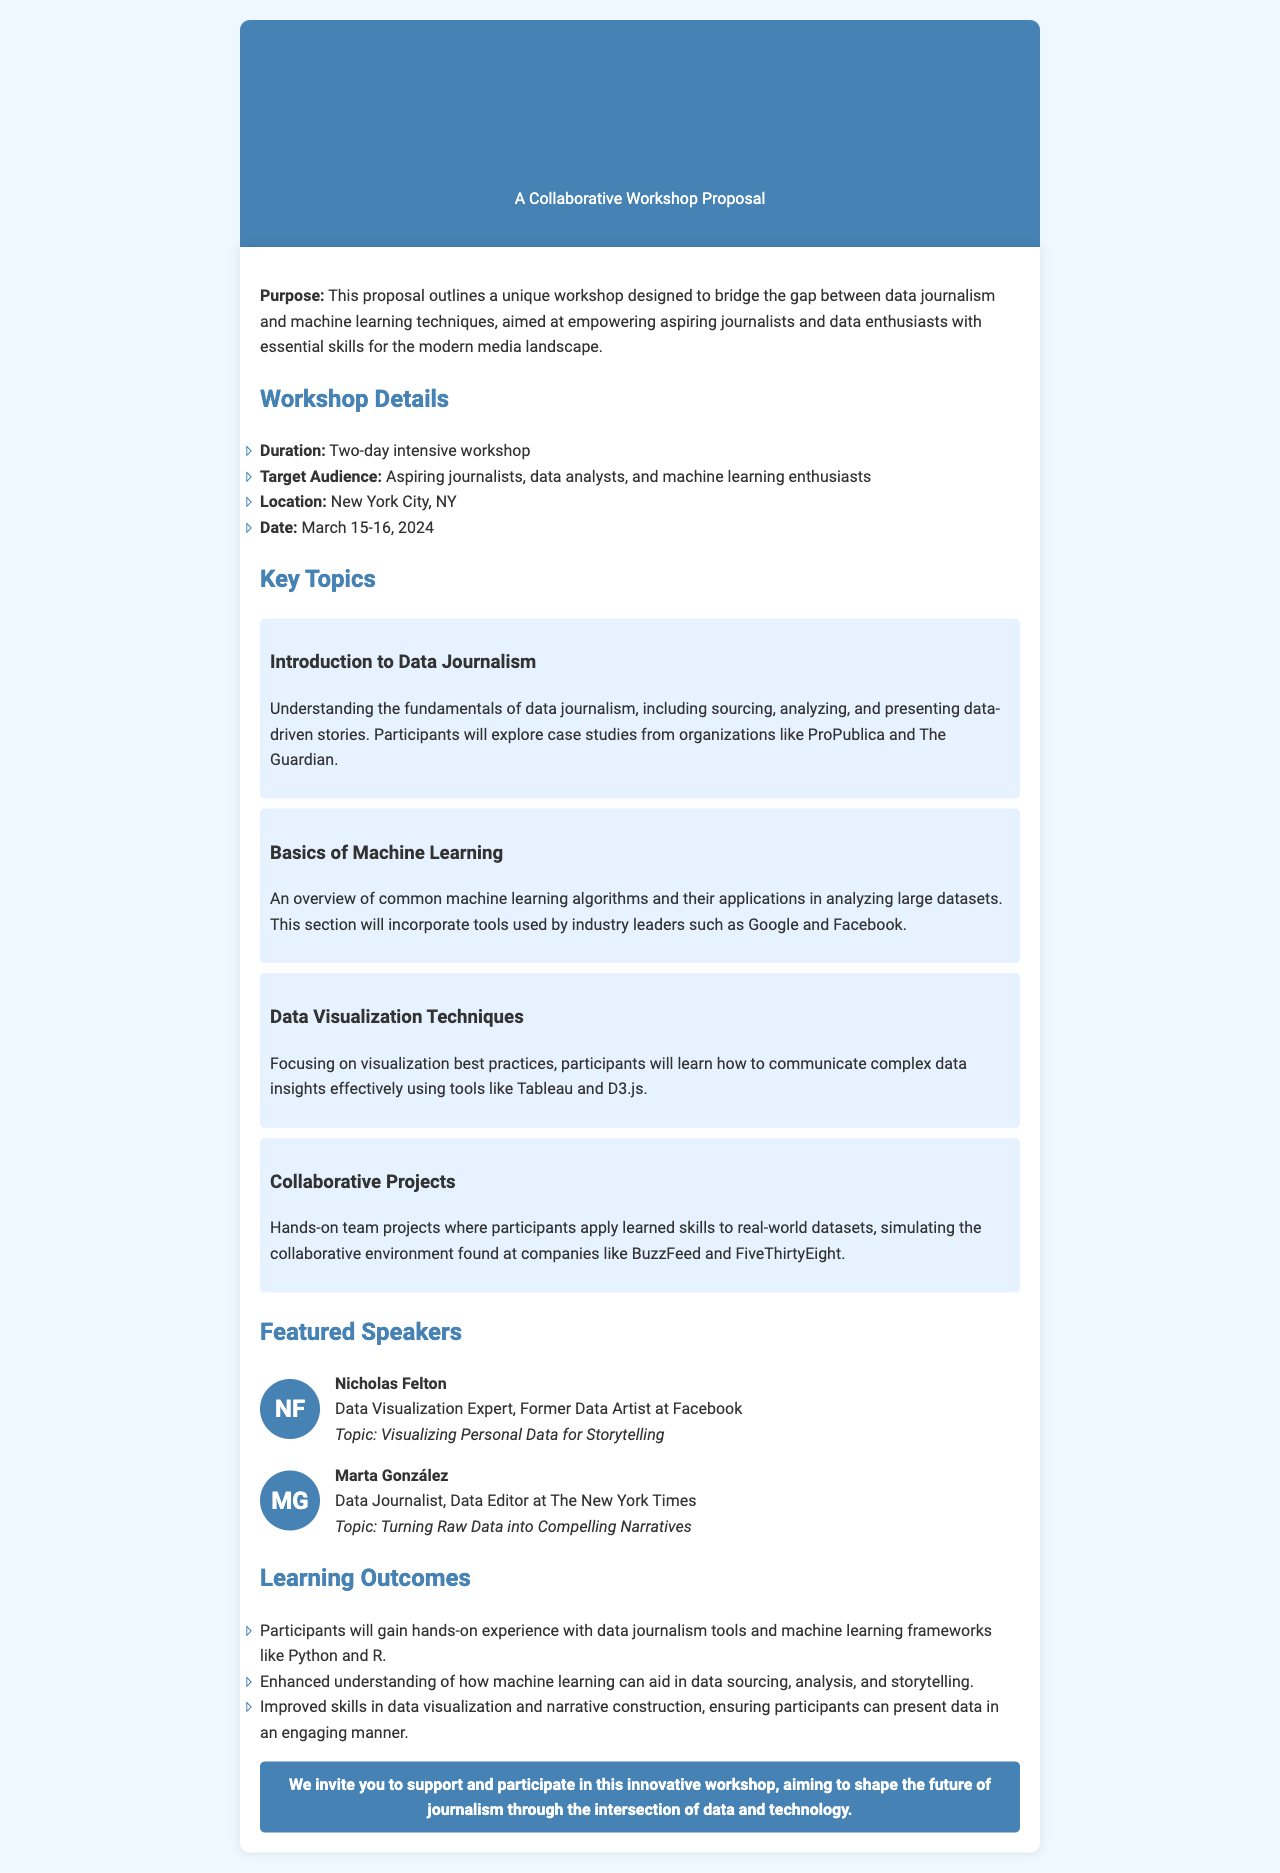What is the title of the workshop proposal? The title of the workshop proposal is stated at the top of the document, emphasizing the collaborative aspect of data journalism and machine learning.
Answer: Data-Driven Storytelling: Leveraging Machine Learning in Journalism What are the workshop dates? The specific dates for the workshop are mentioned under the workshop details section of the document.
Answer: March 15-16, 2024 Who is the data visualization expert speaker? The document lists specific speakers along with their roles and topics, identifying Nicholas Felton as the expert in data visualization.
Answer: Nicholas Felton What is one of the key topics covered in the workshop? The document highlights several key topics; one example is given which explains the content of the workshop.
Answer: Introduction to Data Journalism How long is the workshop? The duration of the workshop is explicitly mentioned in the workshop details section of the document.
Answer: Two-day intensive workshop What location will the workshop be held? The document specifies the venue for the workshop, providing locality information.
Answer: New York City, NY Which machine learning techniques will be introduced? The document provides an overview of topics and mentions the introduction of common algorithms related to machine learning.
Answer: Basics of Machine Learning What is one learning outcome for participants? The document outlines expected outcomes for attendees, demonstrating the educational objectives of the workshop.
Answer: Hands-on experience with data journalism tools and machine learning frameworks Who is the data editor speaker? The document lists the roles of various speakers and designates one speaker as a data editor at a prominent newspaper.
Answer: Marta González 